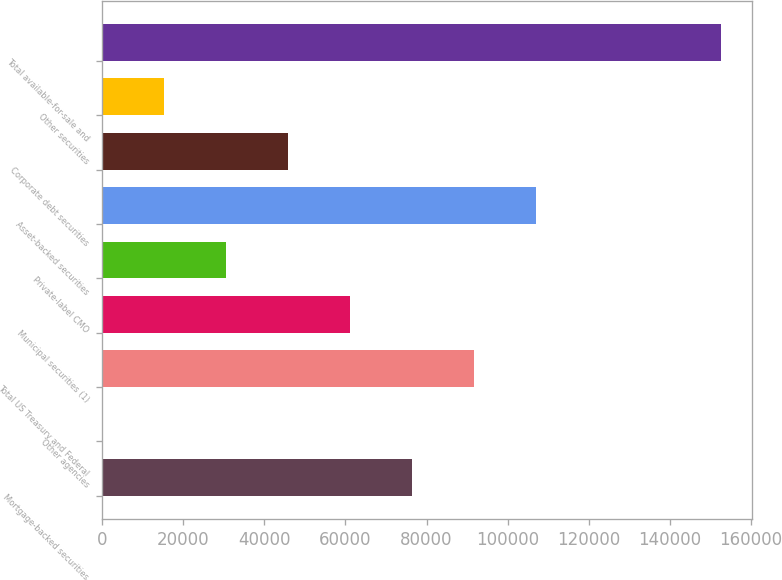<chart> <loc_0><loc_0><loc_500><loc_500><bar_chart><fcel>Mortgage-backed securities<fcel>Other agencies<fcel>Total US Treasury and Federal<fcel>Municipal securities (1)<fcel>Private-label CMO<fcel>Asset-backed securities<fcel>Corporate debt securities<fcel>Other securities<fcel>Total available-for-sale and<nl><fcel>76395<fcel>94<fcel>91655.2<fcel>61134.8<fcel>30614.4<fcel>106915<fcel>45874.6<fcel>15354.2<fcel>152696<nl></chart> 